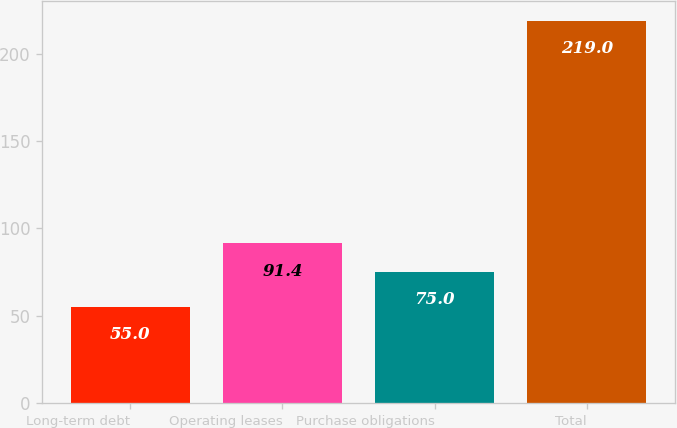Convert chart. <chart><loc_0><loc_0><loc_500><loc_500><bar_chart><fcel>Long-term debt<fcel>Operating leases<fcel>Purchase obligations<fcel>Total<nl><fcel>55<fcel>91.4<fcel>75<fcel>219<nl></chart> 